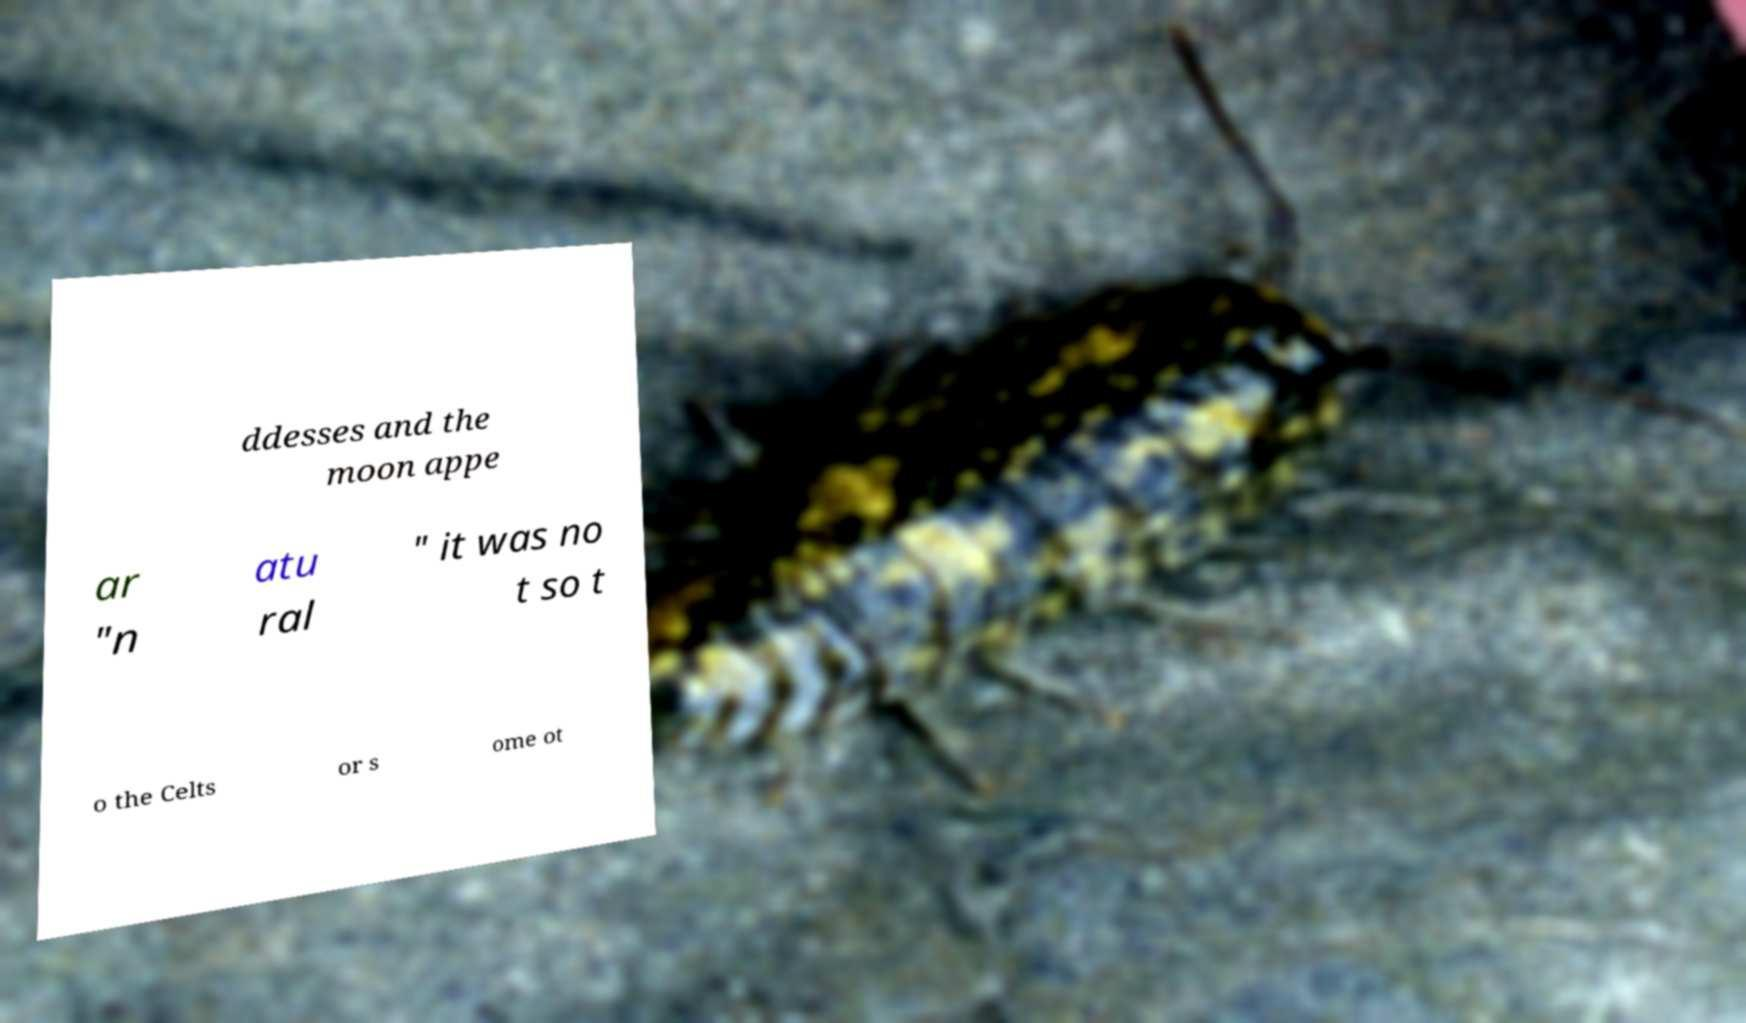Can you accurately transcribe the text from the provided image for me? ddesses and the moon appe ar "n atu ral " it was no t so t o the Celts or s ome ot 